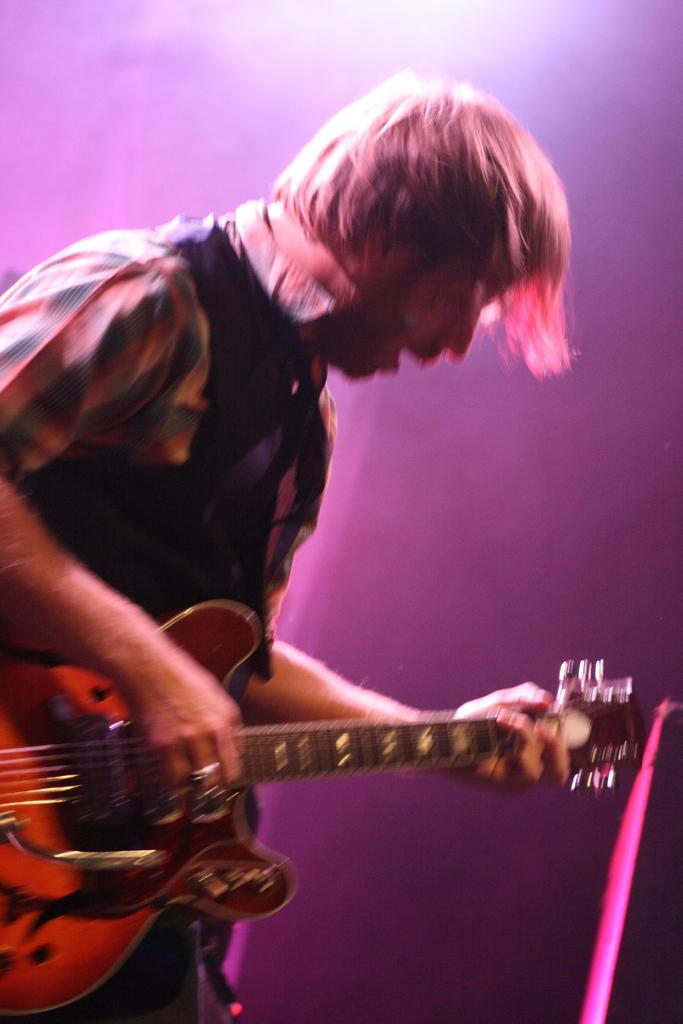Who is the main subject in the image? There is a boy in the image. Where is the boy positioned in the image? The boy is standing at the left side of the image. What is the boy holding in his hands? The boy is holding a guitar in his hands. What kind of trouble is the boy causing with his hands in the image? There is no indication of trouble or any negative actions in the image; the boy is simply holding a guitar. 